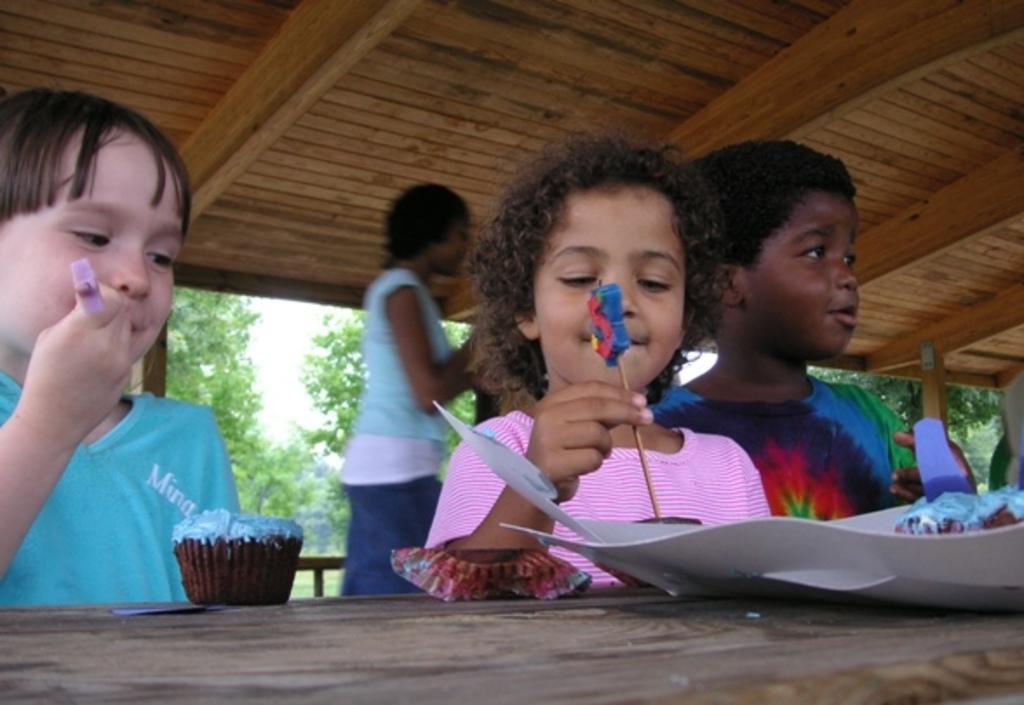Please provide a concise description of this image. This image is taken in outdoors. There are four people in this image, three kids and a woman. At the background there is a sky and many trees. At the top of the image there is a roof. At the bottom of the image table there is a which has cup cake and a tray on it. In the left side of the image there is kid. In the middle of the image there is a woman and a kid. In the right side of the image there is a kid standing on the floor. 